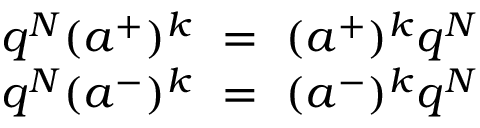<formula> <loc_0><loc_0><loc_500><loc_500>\begin{array} { c } { { q ^ { N } ( a ^ { + } ) ^ { k } = ( a ^ { + } ) ^ { k } q ^ { N } } } \\ { { q ^ { N } ( a ^ { - } ) ^ { k } = ( a ^ { - } ) ^ { k } q ^ { N } } } \end{array}</formula> 